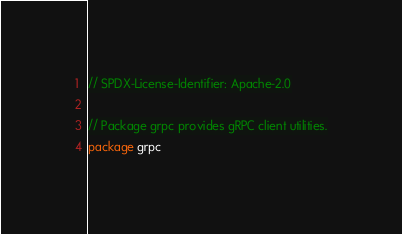Convert code to text. <code><loc_0><loc_0><loc_500><loc_500><_Go_>// SPDX-License-Identifier: Apache-2.0

// Package grpc provides gRPC client utilities.
package grpc
</code> 